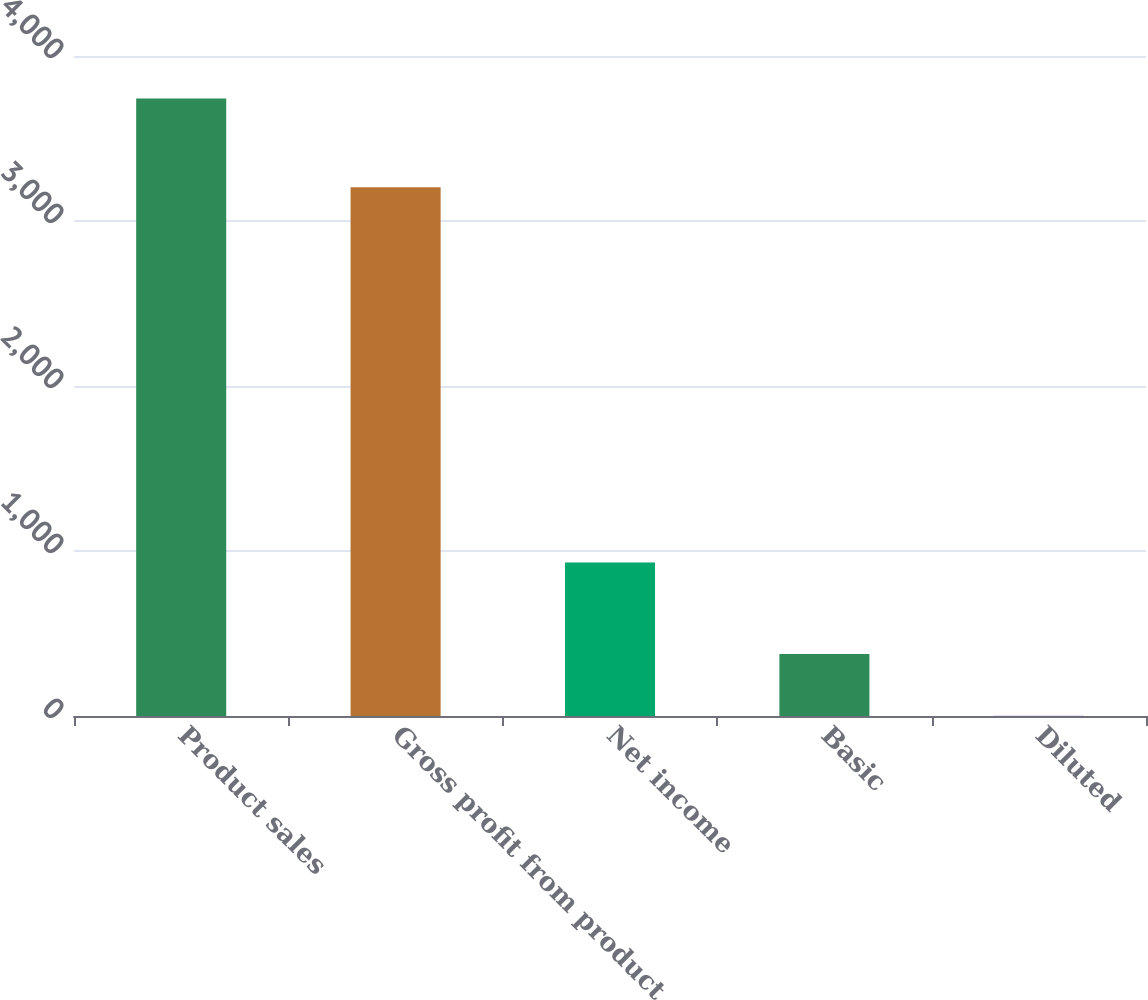<chart> <loc_0><loc_0><loc_500><loc_500><bar_chart><fcel>Product sales<fcel>Gross profit from product<fcel>Net income<fcel>Basic<fcel>Diluted<nl><fcel>3743<fcel>3205<fcel>931<fcel>375.13<fcel>0.92<nl></chart> 